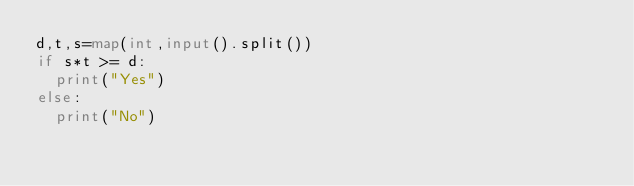<code> <loc_0><loc_0><loc_500><loc_500><_Python_>d,t,s=map(int,input().split())
if s*t >= d:
  print("Yes")
else:
  print("No")</code> 